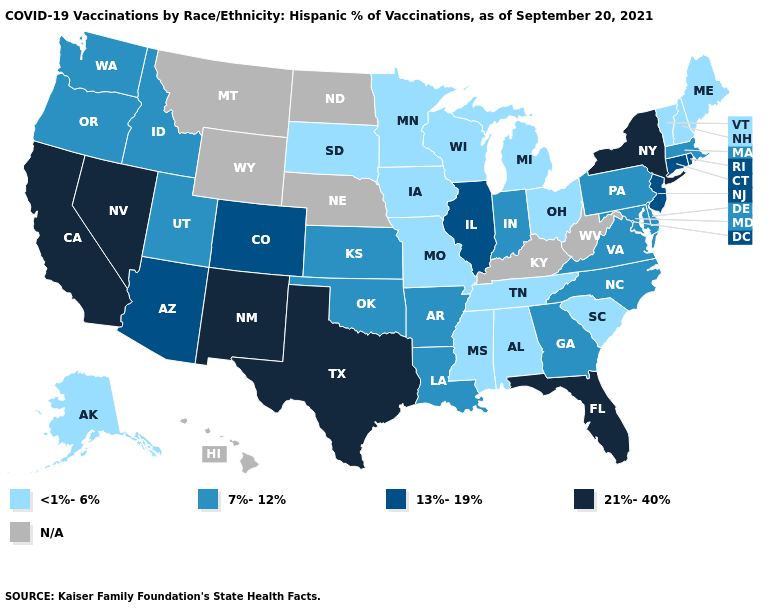What is the value of Alabama?
Keep it brief. <1%-6%. What is the value of Tennessee?
Write a very short answer. <1%-6%. Which states have the lowest value in the USA?
Write a very short answer. Alabama, Alaska, Iowa, Maine, Michigan, Minnesota, Mississippi, Missouri, New Hampshire, Ohio, South Carolina, South Dakota, Tennessee, Vermont, Wisconsin. Which states hav the highest value in the MidWest?
Be succinct. Illinois. Which states have the lowest value in the USA?
Keep it brief. Alabama, Alaska, Iowa, Maine, Michigan, Minnesota, Mississippi, Missouri, New Hampshire, Ohio, South Carolina, South Dakota, Tennessee, Vermont, Wisconsin. What is the highest value in the USA?
Concise answer only. 21%-40%. What is the highest value in states that border Kentucky?
Be succinct. 13%-19%. Among the states that border Ohio , which have the highest value?
Give a very brief answer. Indiana, Pennsylvania. Among the states that border Louisiana , which have the highest value?
Be succinct. Texas. Does Maryland have the highest value in the South?
Answer briefly. No. Name the states that have a value in the range N/A?
Keep it brief. Hawaii, Kentucky, Montana, Nebraska, North Dakota, West Virginia, Wyoming. How many symbols are there in the legend?
Give a very brief answer. 5. Name the states that have a value in the range 13%-19%?
Write a very short answer. Arizona, Colorado, Connecticut, Illinois, New Jersey, Rhode Island. 